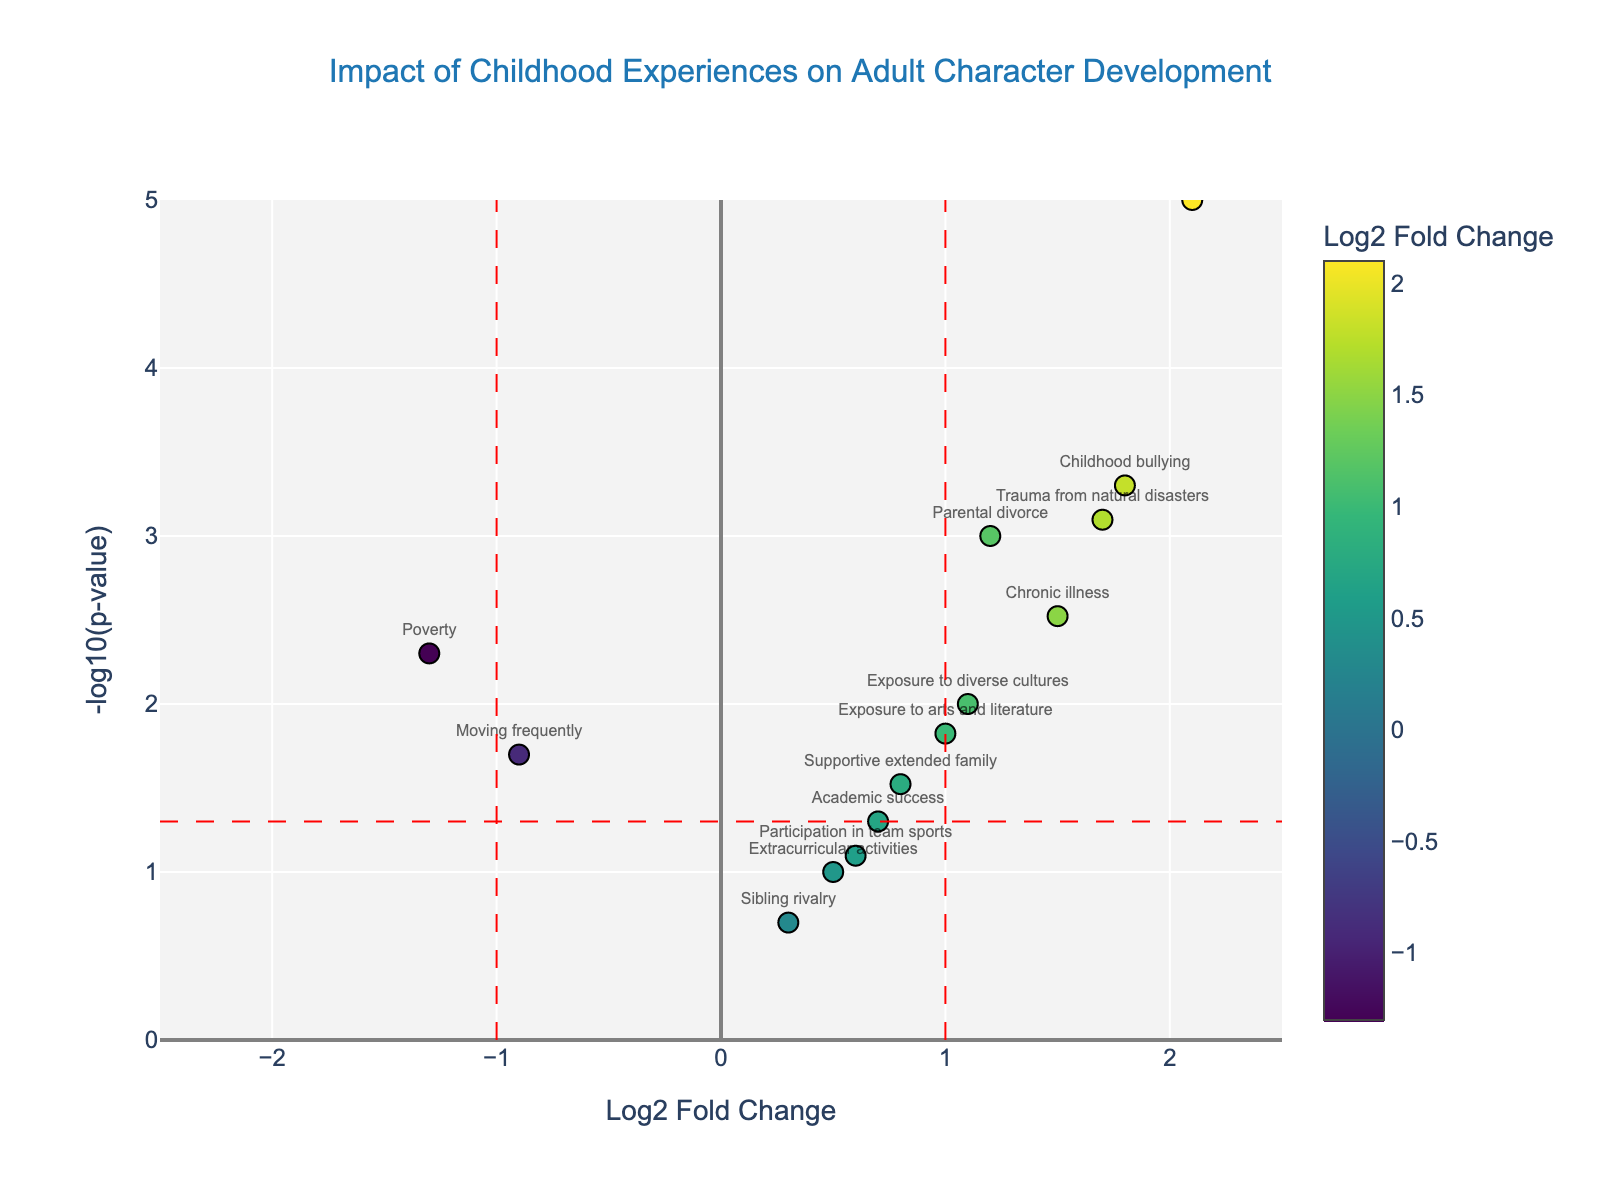What is the impact of 'Early loss of a parent' on adult character development? To determine the impact, find 'Early loss of a parent' on the plot. The log2 fold change is 2.1, and the p-value is extremely low (0.00001). This suggests a highly significant and strong positive impact.
Answer: Highly significant, strong positive impact Which childhood experience has the lowest p-value? To find the lowest p-value, look for the highest point on the y-axis (-log10(p-value)) because lower p-values correspond to higher -log10(p-value) values. 'Early loss of a parent' reaches the highest point on the y-axis.
Answer: Early loss of a parent How many childhood experiences have a statistically significant impact (p-value < 0.05)? Identify all points above the horizontal threshold line at y = -log10(0.05). These points represent statistically significant results. Count the points above this line.
Answer: 9 Which experience shows the most negative impact on adult character development, and how significant is it? Find the point with the lowest log2 fold change on the x-axis. 'Poverty' has a log2 fold change of -1.3. Check its p-value using the y-axis value (-log10(p-value)); it's around 0.005, making it statistically significant.
Answer: Poverty, significant Is the impact of 'Exposure to arts and literature' statistically significant? Locate 'Exposure to arts and literature' on the plot and check if it's above the y = -log10(0.05) line (statistical significance threshold). It is above this line, hence significant.
Answer: Yes Which two experiences appear closest together in both impact and significance? Look for the two points that are nearest to each other on both axes. 'Participation in team sports' and 'Extracurricular activities' are proximate with log2 fold changes around 0.5-0.6 and -log10(p-values) below 1.
Answer: Participation in team sports and Extracurricular activities What is the log2 fold change for 'Childhood bullying' and how does it compare to 'Parental divorce'? Identify 'Childhood bullying' and 'Parental divorce' on the x-axis. 'Childhood bullying' has a log2 fold change of 1.8, and 'Parental divorce' has 1.2. Compare these values directly.
Answer: 1.8, higher than Parental divorce (1.2) Between 'Parental divorce' and 'Poverty', which has a more significant p-value? Check both experiences on the plot and compare their positions on the y-axis. 'Parental divorce' has a -log10(p-value) of 3 and 'Poverty' has a -log10(p-value) of nearly 2.8, meaning 'Parental divorce' has a more significant p-value.
Answer: Parental divorce What color represents the point for 'Supportive extended family', and what does this suggest about its impact? Identify the point for 'Supportive extended family' and note its color on the color scale, which is based on log2 fold change values. It falls within a yellow-green color, indicating a positive log2 fold change of 0.8.
Answer: Yellow-green, positive impact Where does 'Childhood bullying' fall concerning the threshold lines at log2 fold change ± 1? Locate 'Childhood bullying' and observe its position relative to the vertical lines at x = -1 and x = 1. 'Childhood bullying' is well above the positive threshold (x = 1).
Answer: Above the positive threshold line (x = 1) 